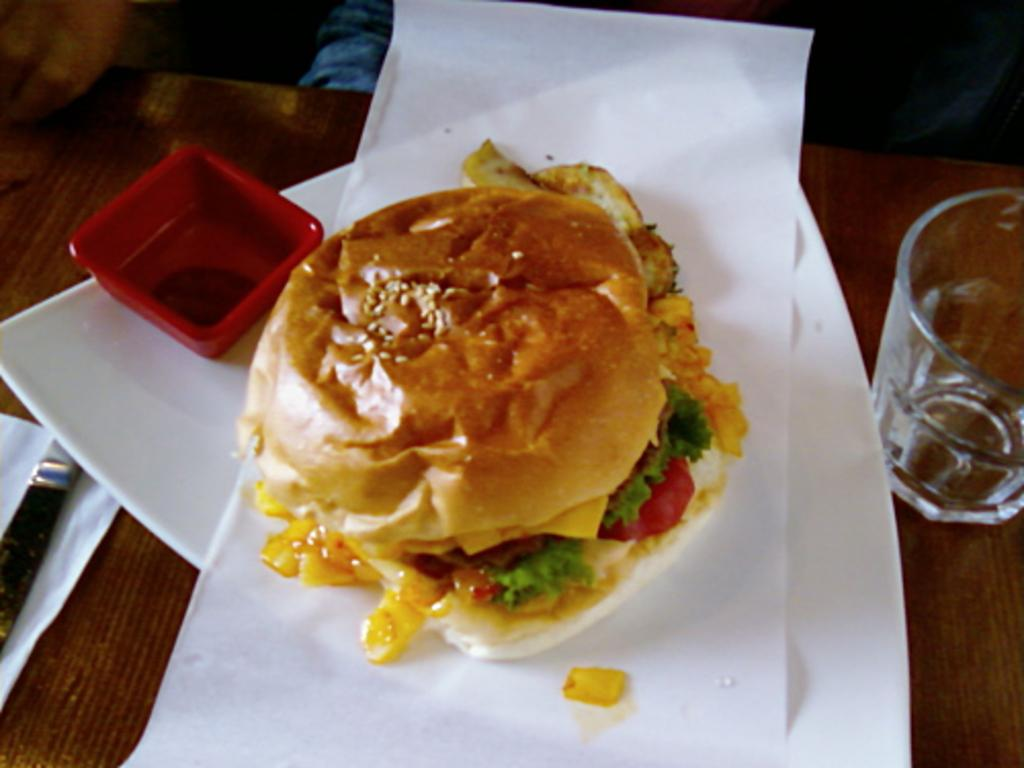What type of surface is in the image? There is a wooden platform in the image. What objects are on the wooden platform? A plate, a bowl, a glass, food, a knife, and tissue papers are on the wooden platform. What might be used for cutting in the image? A knife is on the wooden platform. What items are present for cleaning or wiping in the image? Tissue papers are on the wooden platform. What type of songs can be heard coming from the quiver in the image? There is no quiver or songs present in the image; it features a wooden platform with various objects on it. 